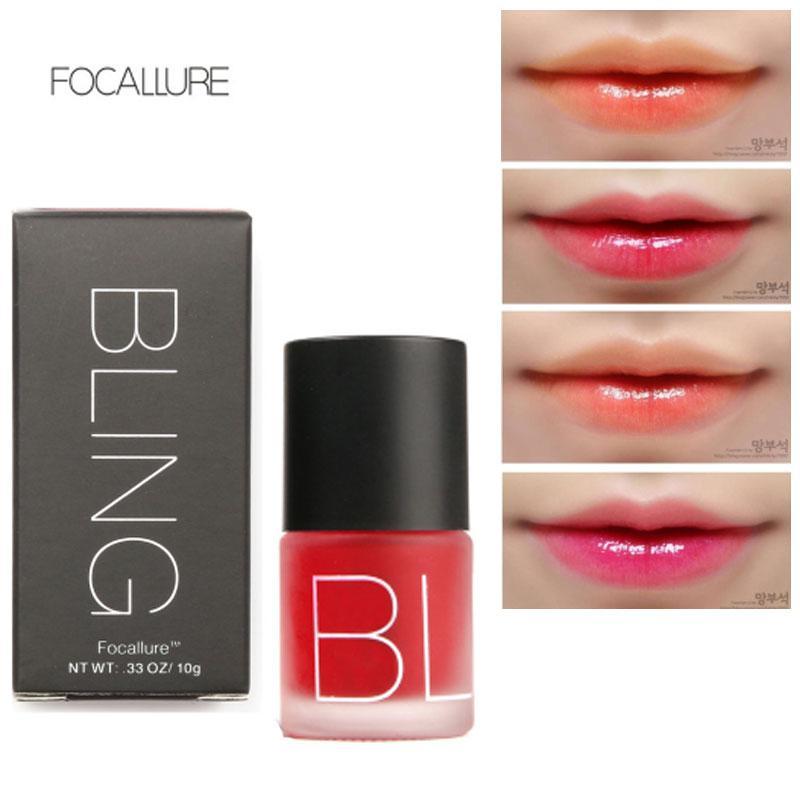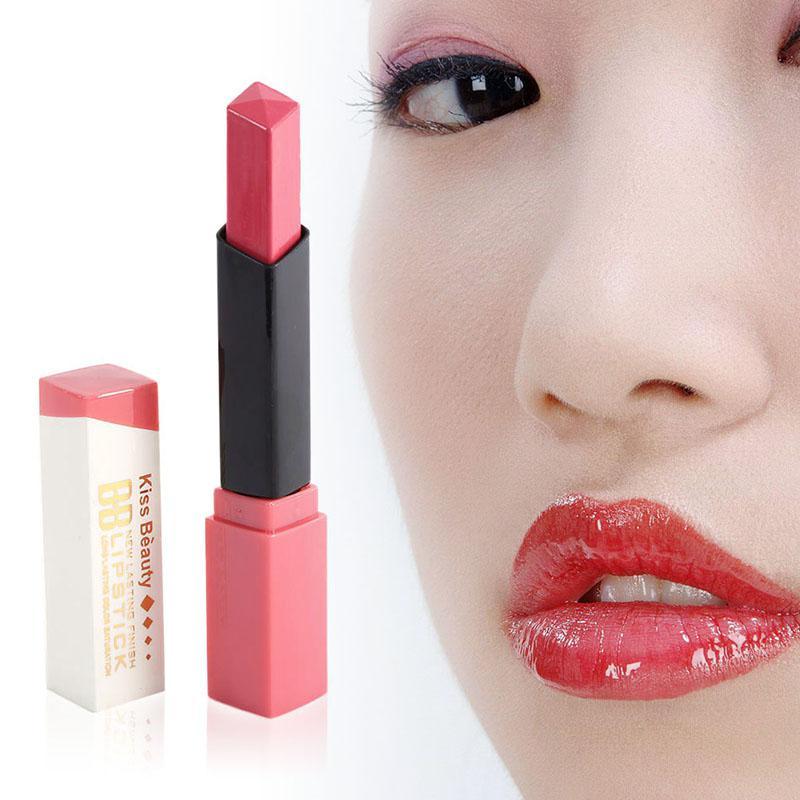The first image is the image on the left, the second image is the image on the right. Considering the images on both sides, is "In one image, a person's face is shown to demonstrate a specific lip color." valid? Answer yes or no. Yes. 